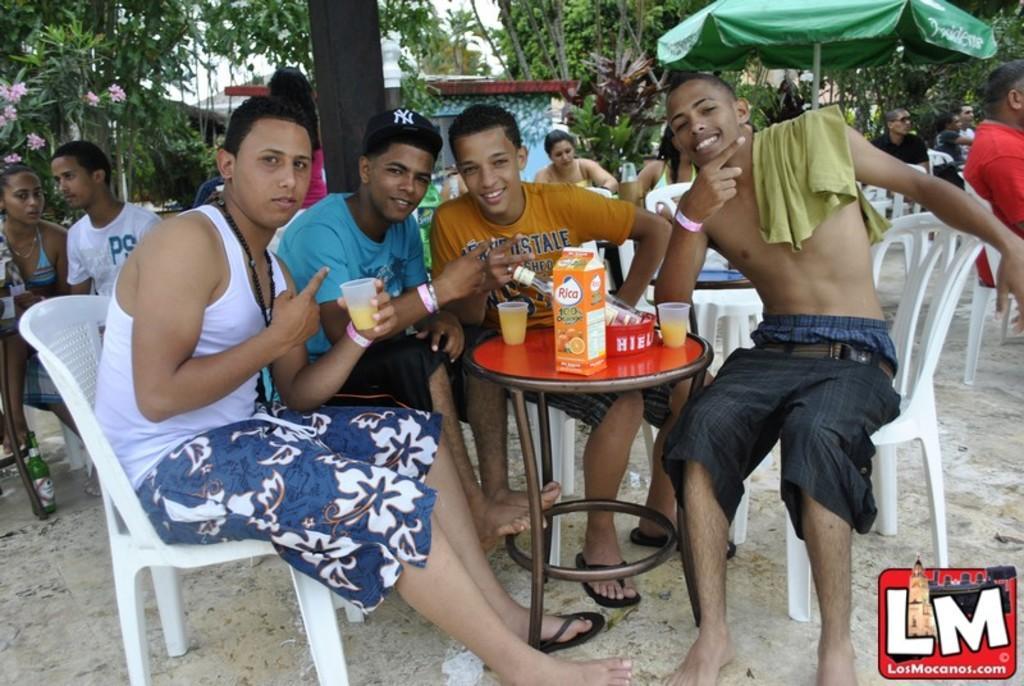Could you give a brief overview of what you see in this image? There are a four people who are sitting on a chair and having a drink. In the background we can see a tent and few people and trees. 